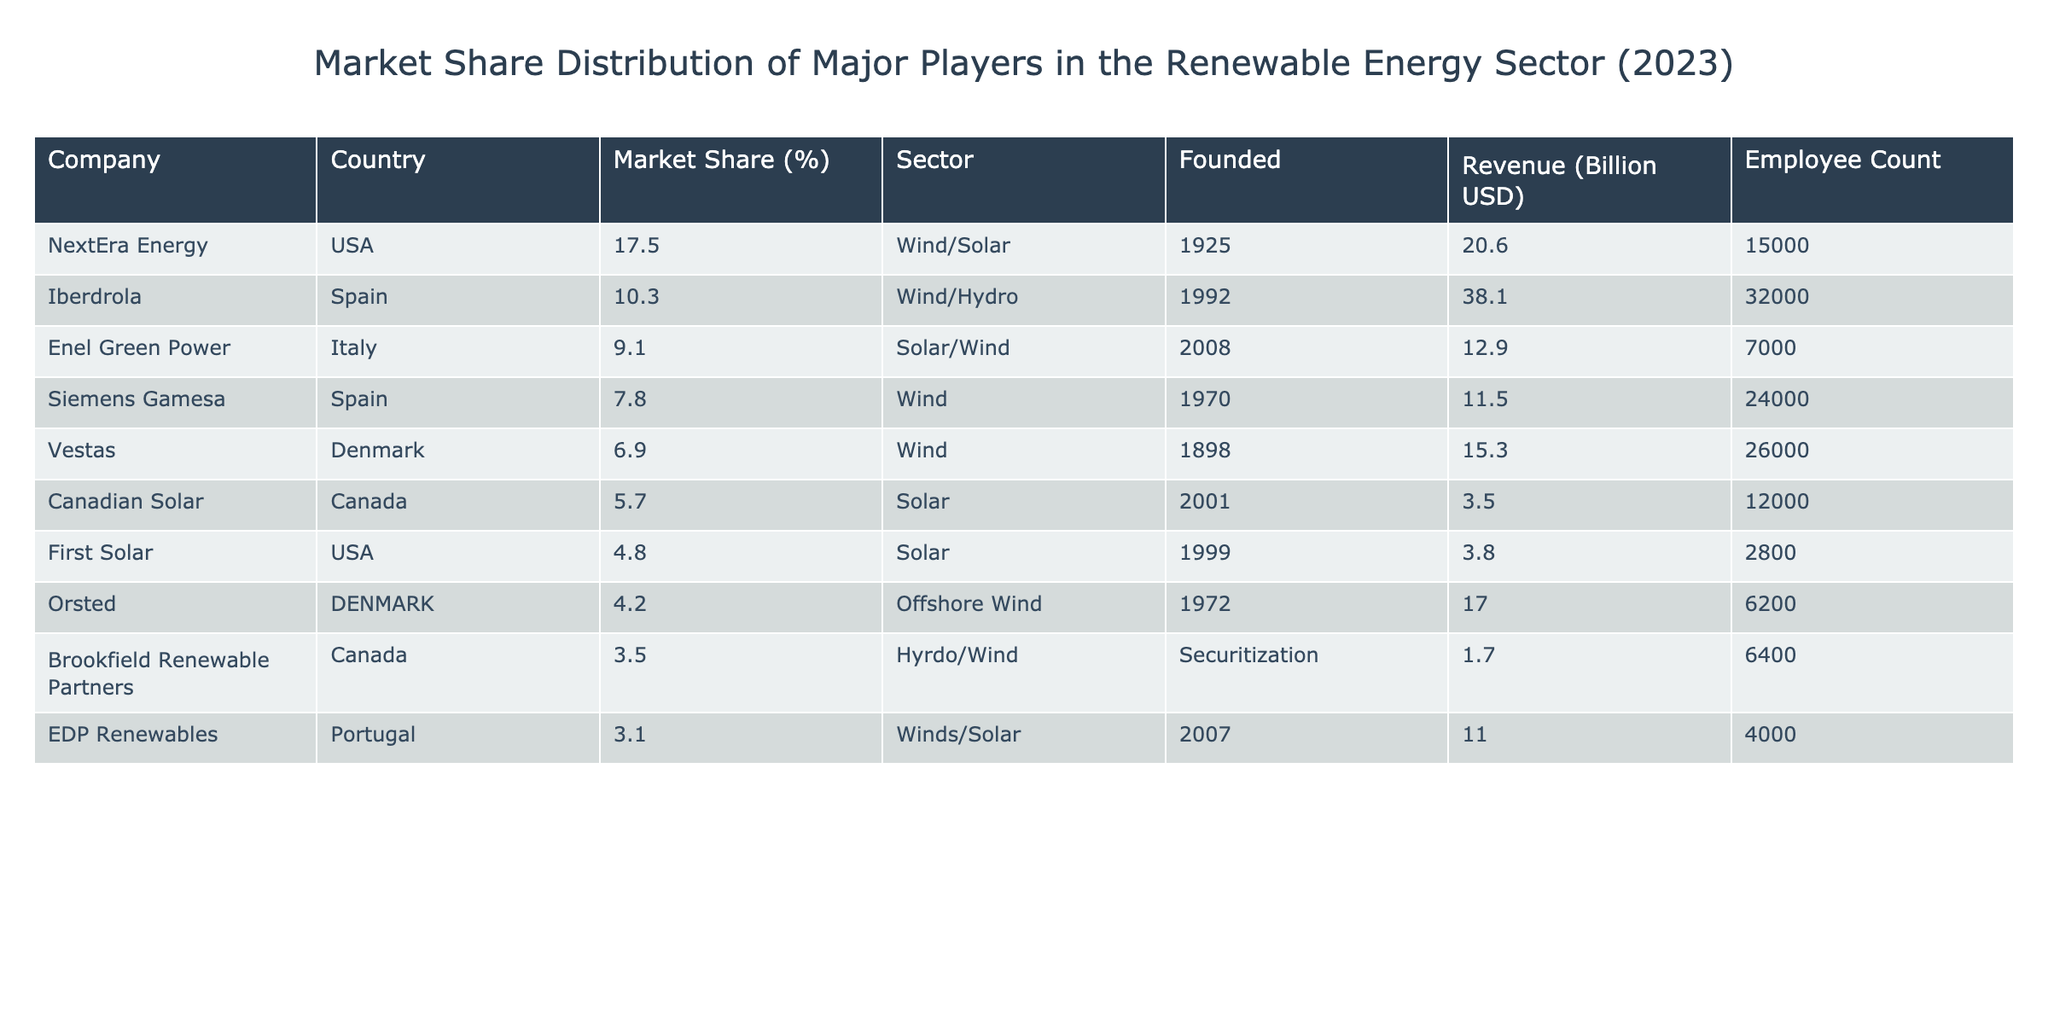What company has the highest market share in the renewable energy sector in 2023? The table lists the companies along with their market shares, and it's clear that NextEra Energy has the highest market share at 17.5%.
Answer: NextEra Energy What percentage of the market share do companies from Spain hold? The two companies from Spain in the table are Iberdrola with 10.3% and Siemens Gamesa with 7.8%. Adding these gives 10.3 + 7.8 = 18.1%.
Answer: 18.1% Is Orsted a company that specializes in Solar energy? Orsted operates in the Offshore Wind sector, as indicated in the table. This means the statement is false.
Answer: No What is the combined market share of the top three companies listed? The top three companies are NextEra Energy (17.5%), Iberdrola (10.3%), and Enel Green Power (9.1%). Their combined market share is 17.5 + 10.3 + 9.1 = 37.0%.
Answer: 37.0% Which sector has the highest representation in terms of market share among the listed companies? The sectors represented are Wind, Solar, Hydro, and Offshore Wind. By reviewing the market shares, Wind/Solar (NextEra Energy), Wind/Hydro (Iberdrola), and others, we can find that Wind collectively holds a strong position. They sum significantly to more than others cumulatively; combining their market share shows Wind has the largest hold.
Answer: Wind How many companies have a market share greater than 5%? From the table, the companies with market share greater than 5% are NextEra Energy, Iberdrola, Enel Green Power, Siemens Gamesa, and Vestas. Counting these gives a total of 5 companies.
Answer: 5 What is the average revenue of the companies listed in the table? To find the average revenue, add together the revenues of all the companies (20.6 + 38.1 + 12.9 + 11.5 + 15.3 + 3.5 + 3.8 + 17.0 + 1.7 + 11.0 = 134.4) and divide by the number of companies (10), giving an average of 134.4 / 10 = 13.44 billion USD.
Answer: 13.44 billion USD Does Canada have more than one company listed in the market share table? The table lists two companies from Canada: Canadian Solar and Brookfield Renewable Partners, which confirms that the statement is true.
Answer: Yes Which company has the lowest employee count among the listed major players? Reviewing the employee counts, First Solar has the lowest count at 2800.
Answer: First Solar 